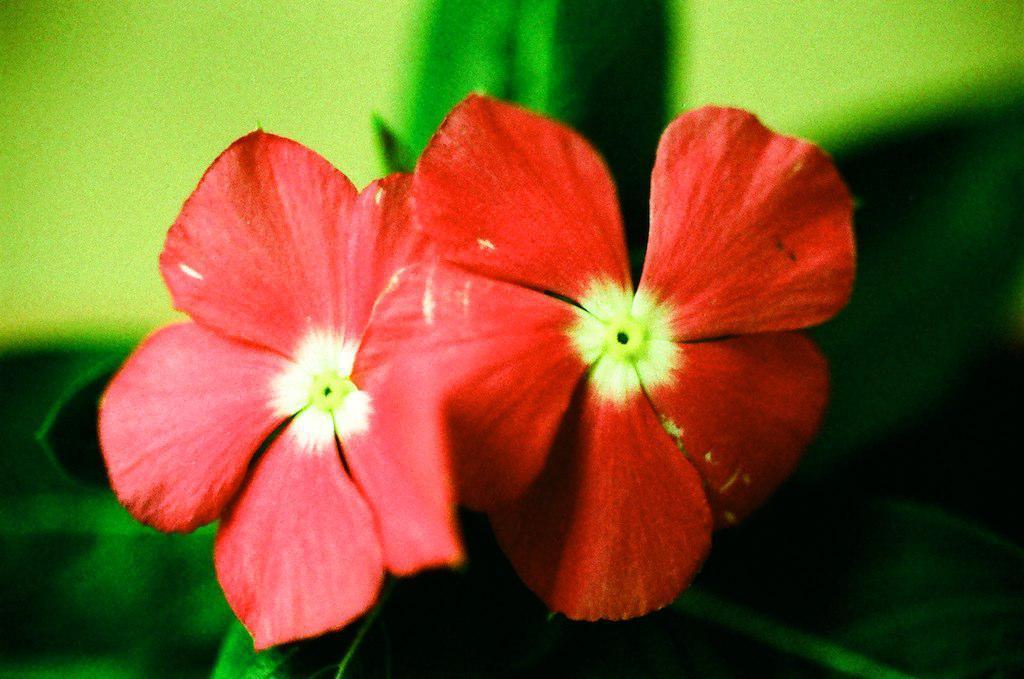Can you describe this image briefly? In this image we can see two flowers and the blurred background. 